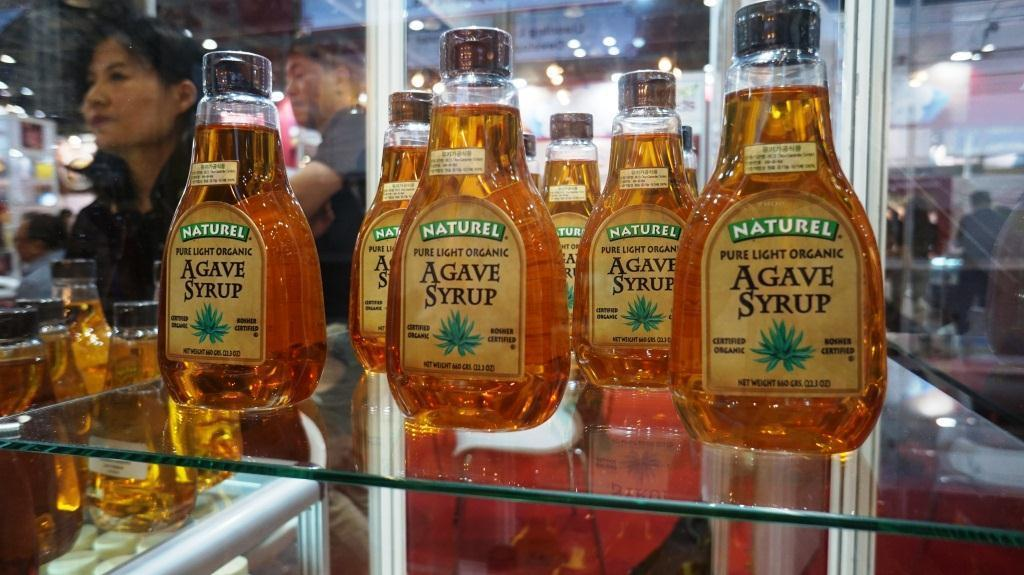Provide a one-sentence caption for the provided image. A few bottles of Naturel Agave Syrup on a glass shelf. 